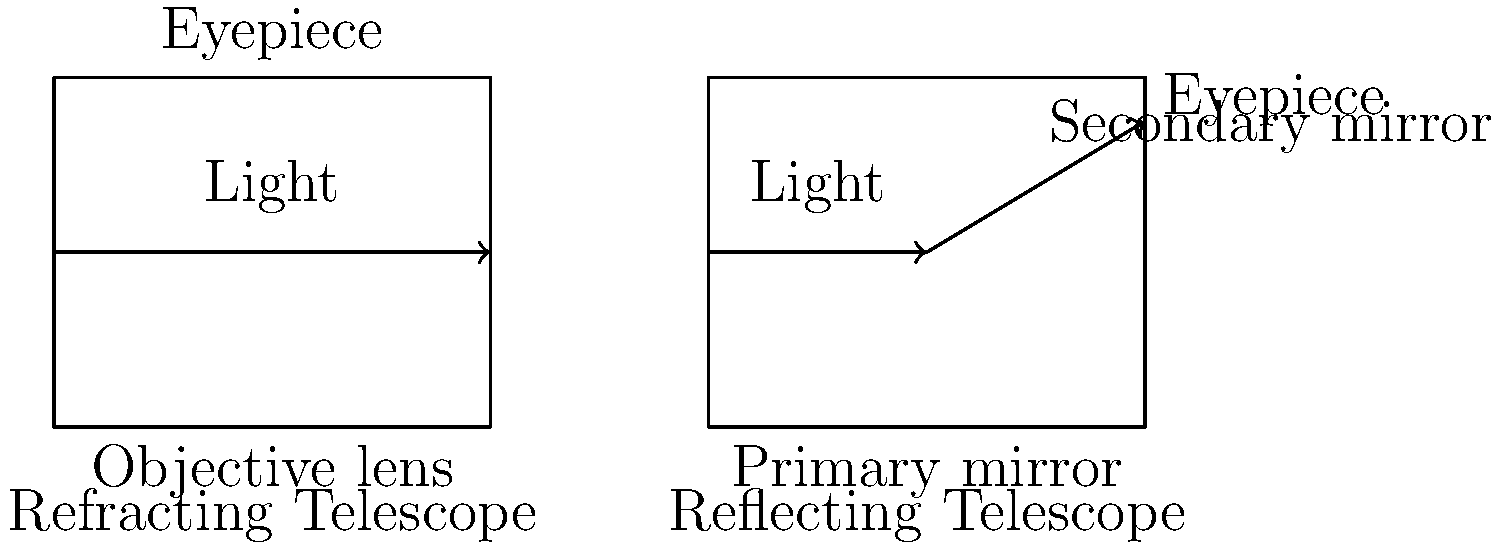As a software engineer with an appreciation for both technology and the humanities, you understand the importance of diverse tools in different fields. In astronomy, various types of telescopes are used to observe celestial objects. Based on the diagram, what are the main differences between refracting and reflecting telescopes in terms of their basic design and how they manipulate light? To answer this question, let's analyze the key components and light paths in both types of telescopes:

1. Refracting Telescope:
   a. Light enters from the left side.
   b. The first optical element is the objective lens.
   c. Light passes through the objective lens and is refracted (bent).
   d. The refracted light continues straight to the eyepiece.

2. Reflecting Telescope:
   a. Light enters from the left side.
   b. The first optical element is the primary mirror at the bottom.
   c. Light is reflected off the primary mirror towards the top of the telescope.
   d. A secondary mirror near the top reflects the light again, directing it to the eyepiece.

Key differences:
1. Primary light manipulation:
   - Refracting telescope: Uses refraction (bending of light through lenses)
   - Reflecting telescope: Uses reflection (bouncing light off mirrors)

2. Main optical elements:
   - Refracting telescope: Objective lens and eyepiece
   - Reflecting telescope: Primary mirror, secondary mirror, and eyepiece

3. Light path:
   - Refracting telescope: Straight path through lenses
   - Reflecting telescope: Folded path using mirrors

4. Potential for chromatic aberration:
   - Refracting telescope: More susceptible due to light passing through lenses
   - Reflecting telescope: Less susceptible as reflection doesn't cause chromatic dispersion

These differences affect factors such as image quality, telescope size, and maintenance requirements, making each type suitable for different astronomical applications.
Answer: Refracting telescopes use lenses to refract light in a straight path, while reflecting telescopes use mirrors to reflect light in a folded path. 